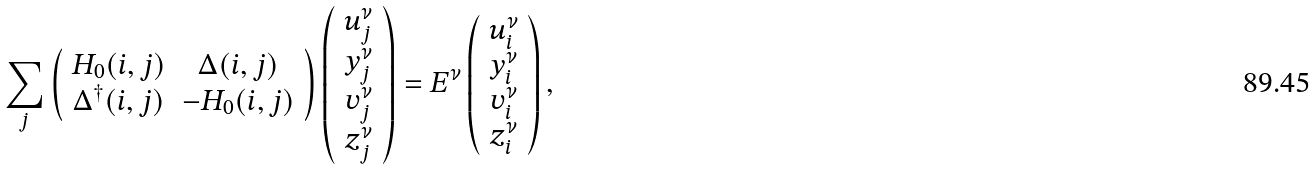<formula> <loc_0><loc_0><loc_500><loc_500>\sum _ { j } \left ( \begin{array} { c c } H _ { 0 } ( { i , j } ) & \Delta ( { i , j } ) \\ \Delta ^ { \dagger } ( { i , j } ) & - H _ { 0 } ( { i , j } ) \end{array} \right ) \left ( \begin{array} { c } u _ { j } ^ { \nu } \\ y _ { j } ^ { \nu } \\ v _ { j } ^ { \nu } \\ z _ { j } ^ { \nu } \end{array} \right ) = E ^ { \nu } \left ( \begin{array} { c } u _ { i } ^ { \nu } \\ y _ { i } ^ { \nu } \\ v _ { i } ^ { \nu } \\ z _ { i } ^ { \nu } \end{array} \right ) ,</formula> 